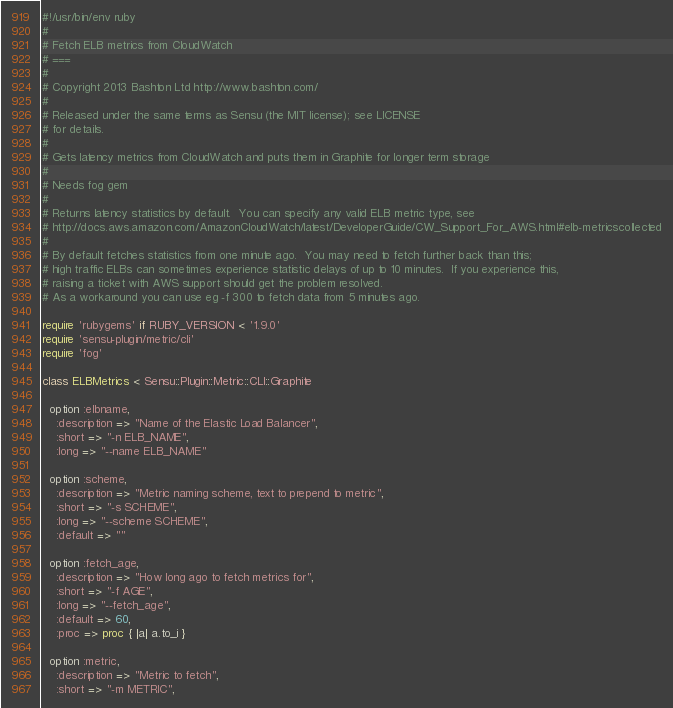<code> <loc_0><loc_0><loc_500><loc_500><_Ruby_>#!/usr/bin/env ruby
#
# Fetch ELB metrics from CloudWatch
# ===
#
# Copyright 2013 Bashton Ltd http://www.bashton.com/
#
# Released under the same terms as Sensu (the MIT license); see LICENSE
# for details.
#
# Gets latency metrics from CloudWatch and puts them in Graphite for longer term storage
#
# Needs fog gem
#
# Returns latency statistics by default.  You can specify any valid ELB metric type, see
# http://docs.aws.amazon.com/AmazonCloudWatch/latest/DeveloperGuide/CW_Support_For_AWS.html#elb-metricscollected
#
# By default fetches statistics from one minute ago.  You may need to fetch further back than this;
# high traffic ELBs can sometimes experience statistic delays of up to 10 minutes.  If you experience this,
# raising a ticket with AWS support should get the problem resolved.
# As a workaround you can use eg -f 300 to fetch data from 5 minutes ago.

require 'rubygems' if RUBY_VERSION < '1.9.0'
require 'sensu-plugin/metric/cli'
require 'fog'

class ELBMetrics < Sensu::Plugin::Metric::CLI::Graphite

  option :elbname,
    :description => "Name of the Elastic Load Balancer",
    :short => "-n ELB_NAME",
    :long => "--name ELB_NAME"

  option :scheme,
    :description => "Metric naming scheme, text to prepend to metric",
    :short => "-s SCHEME",
    :long => "--scheme SCHEME",
    :default => ""

  option :fetch_age,
    :description => "How long ago to fetch metrics for",
    :short => "-f AGE",
    :long => "--fetch_age",
    :default => 60,
    :proc => proc { |a| a.to_i }

  option :metric,
    :description => "Metric to fetch",
    :short => "-m METRIC",</code> 